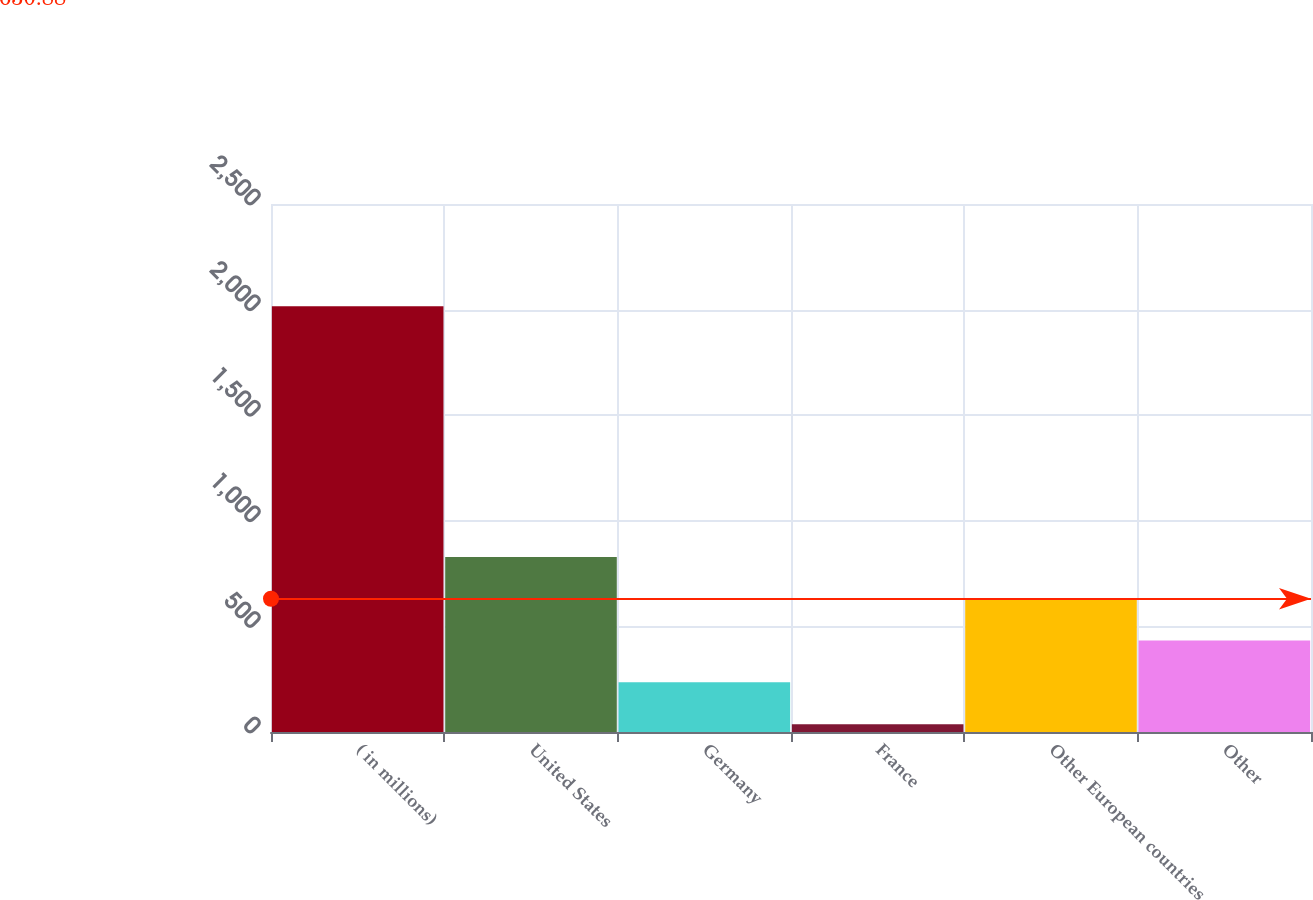Convert chart to OTSL. <chart><loc_0><loc_0><loc_500><loc_500><bar_chart><fcel>( in millions)<fcel>United States<fcel>Germany<fcel>France<fcel>Other European countries<fcel>Other<nl><fcel>2016<fcel>828.66<fcel>234.99<fcel>37.1<fcel>630.77<fcel>432.88<nl></chart> 